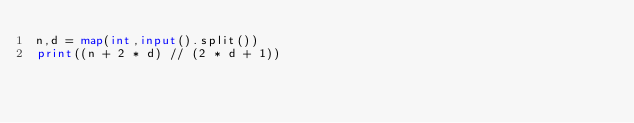Convert code to text. <code><loc_0><loc_0><loc_500><loc_500><_Python_>n,d = map(int,input().split())
print((n + 2 * d) // (2 * d + 1))
</code> 